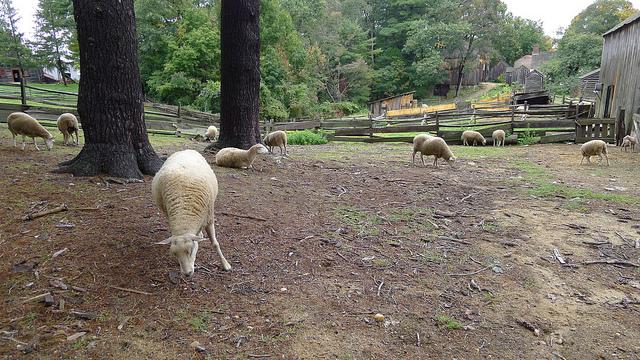What animals are pictured?
Short answer required. Sheep. How many tree trunks do you see?
Be succinct. 2. Is this a barn?
Keep it brief. No. 